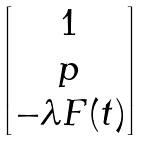<formula> <loc_0><loc_0><loc_500><loc_500>\begin{bmatrix} 1 \\ p \\ - \lambda F ( t ) \end{bmatrix}</formula> 